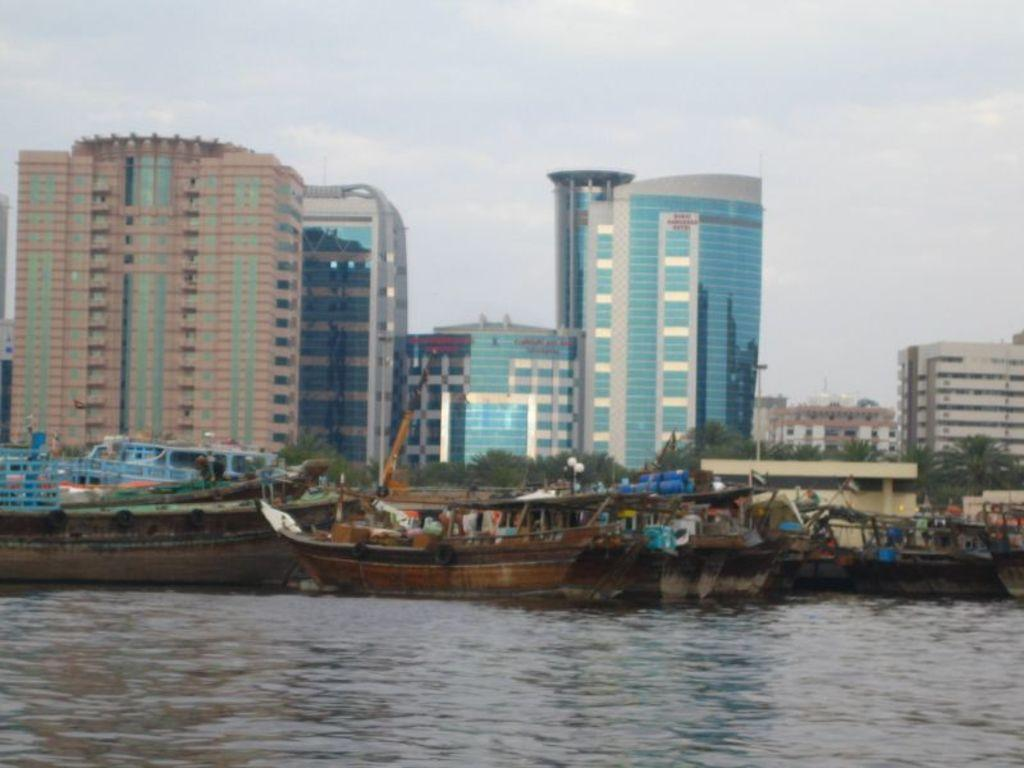What type of structures can be seen in the image? There are buildings in the image. What natural elements are present in the image? There are trees in the image. What type of transportation can be seen on the water in the image? There are boats on the water in the image. Can you see an umbrella being used by someone in the image? There is no umbrella present in the image. What type of stick is being used by the person in the image? There is no person or stick present in the image. 